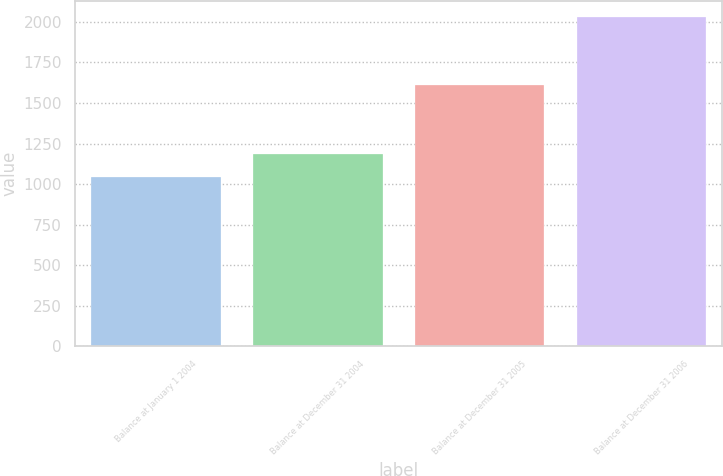<chart> <loc_0><loc_0><loc_500><loc_500><bar_chart><fcel>Balance at January 1 2004<fcel>Balance at December 31 2004<fcel>Balance at December 31 2005<fcel>Balance at December 31 2006<nl><fcel>1043<fcel>1184<fcel>1612<fcel>2029<nl></chart> 